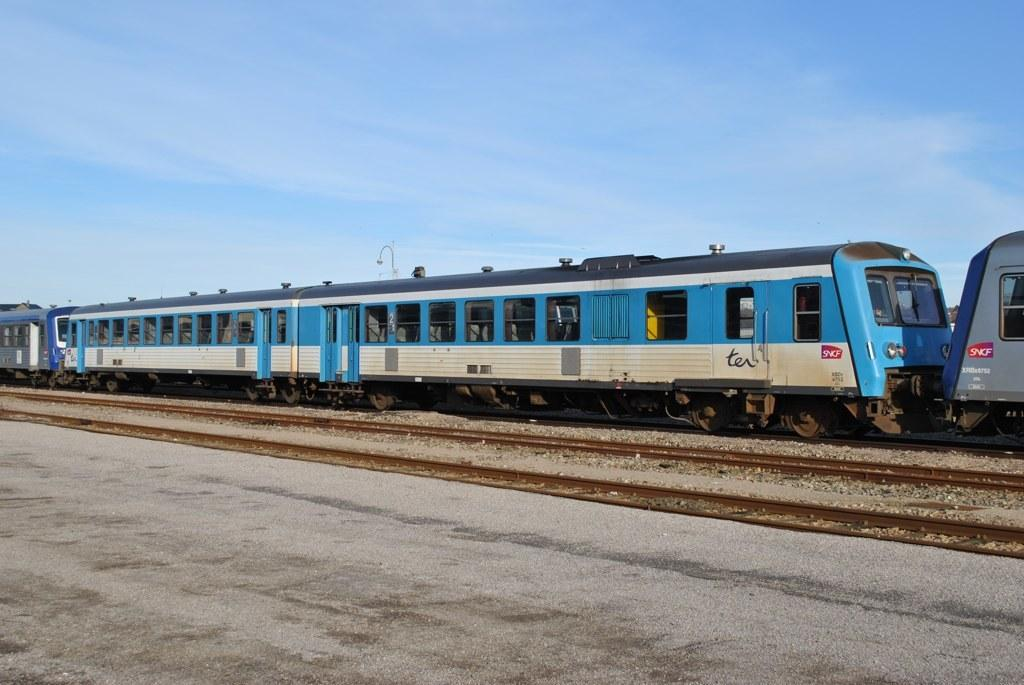What is the main subject of the image? The main subject of the image is a train. What can be seen in the middle of the image? There are tracks in the middle of the image. What type of surface is at the bottom of the image? There is a cement floor at the bottom of the image. What is visible at the top of the image? The sky is visible at the top of the image. What type of bit is being used to harvest the tomatoes in the image? There are no tomatoes or bits present in the image; it features a train on tracks with a cement floor and a visible sky. 